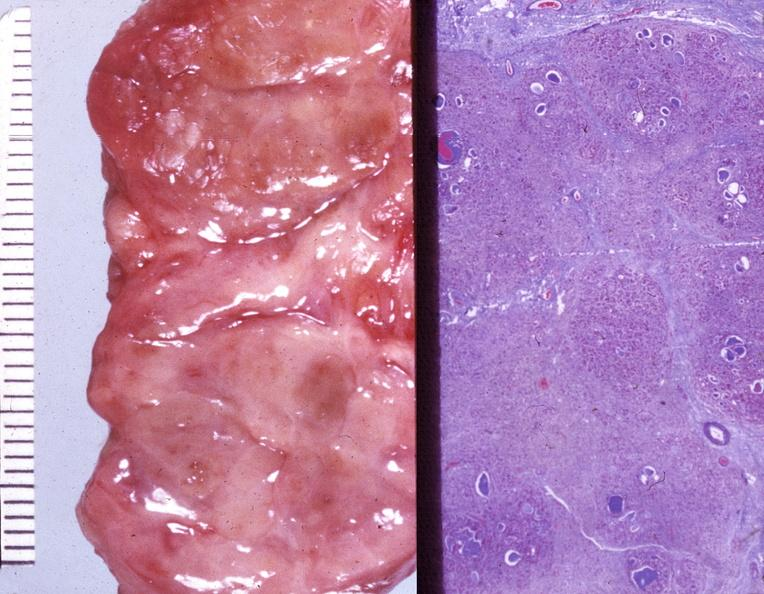s endocrine present?
Answer the question using a single word or phrase. Yes 